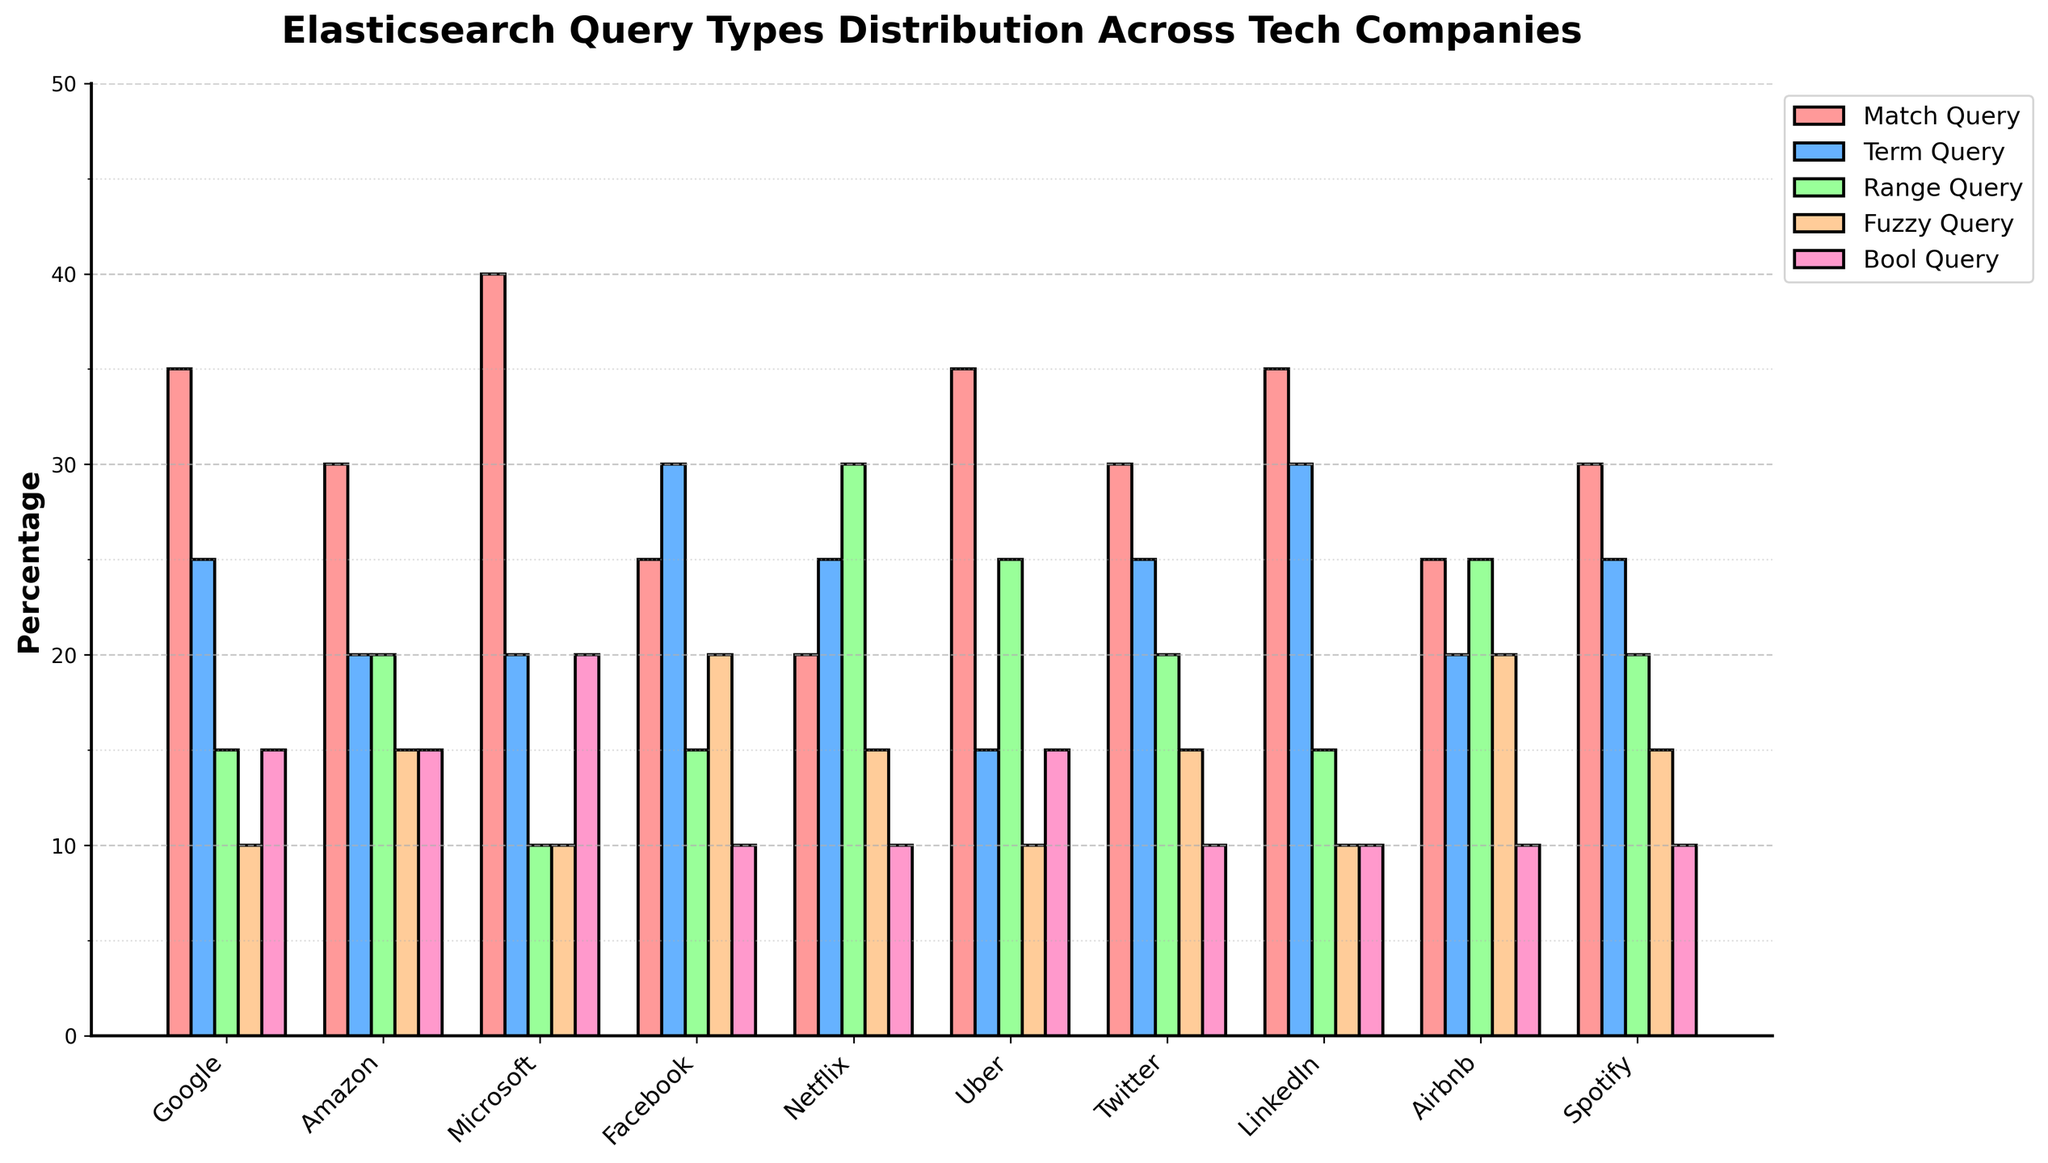Which company uses the Bool Query the most? Looking at the heights of the bars in the Bool Query category, Microsoft has the tallest bar at 20%.
Answer: Microsoft Which company has the least usage of Fuzzy Query? By comparing the heights of the bars for Fuzzy Query, multiple companies (Google, Microsoft, LinkedIn) have the shortest bar at 10%.
Answer: Google, Microsoft, LinkedIn What is the combined percentage of Match Query and Range Query for Uber? The values for Match Query and Range Query for Uber are 35% and 25%, respectively. Adding these together gives 60%.
Answer: 60% Between Twitter and LinkedIn, which company uses Term Query more? By comparing the heights of the bars for Term Query, LinkedIn has a taller bar at 30% compared to Twitter's 25%.
Answer: LinkedIn How many companies use Fuzzy Query more than 15%? By analyzing the heights of the bars, Facebook and Airbnb have Fuzzy Query usage of more than 15%, specifically at 20%. Only these two companies meet the criterion.
Answer: 2 Which query type has the most diverse distribution across all companies? Examining the range of heights of the bars, Range Query spans from 10% to 30%, suggesting it has the most diverse distribution compared to other query types.
Answer: Range Query How does Amazon's usage of Bool Query compare to Facebook's? Amazon and Facebook both have equal height bars for Bool Query at 15%.
Answer: Equal What is the average usage of Term Query across all companies? Summing the percentages: 25 + 20 + 20 + 30 + 25 + 15 + 25 + 30 + 20 + 25 = 235. Dividing by 10 companies, the average is 23.5%.
Answer: 23.5% Which company has an equal usage percentage for Match Query and Bool Query? Airbnb has 25% for both Match Query and Bool Query.
Answer: Airbnb 